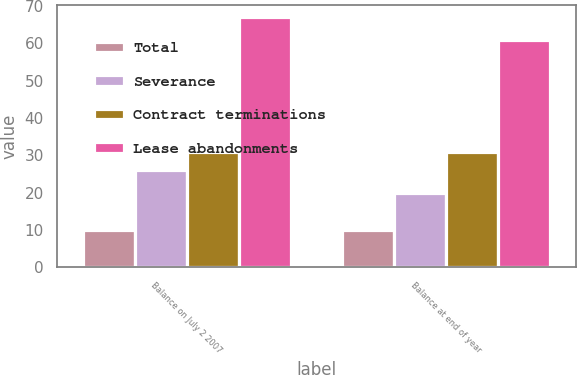<chart> <loc_0><loc_0><loc_500><loc_500><stacked_bar_chart><ecel><fcel>Balance on July 2 2007<fcel>Balance at end of year<nl><fcel>Total<fcel>10<fcel>10<nl><fcel>Severance<fcel>26<fcel>20<nl><fcel>Contract terminations<fcel>31<fcel>31<nl><fcel>Lease abandonments<fcel>67<fcel>61<nl></chart> 